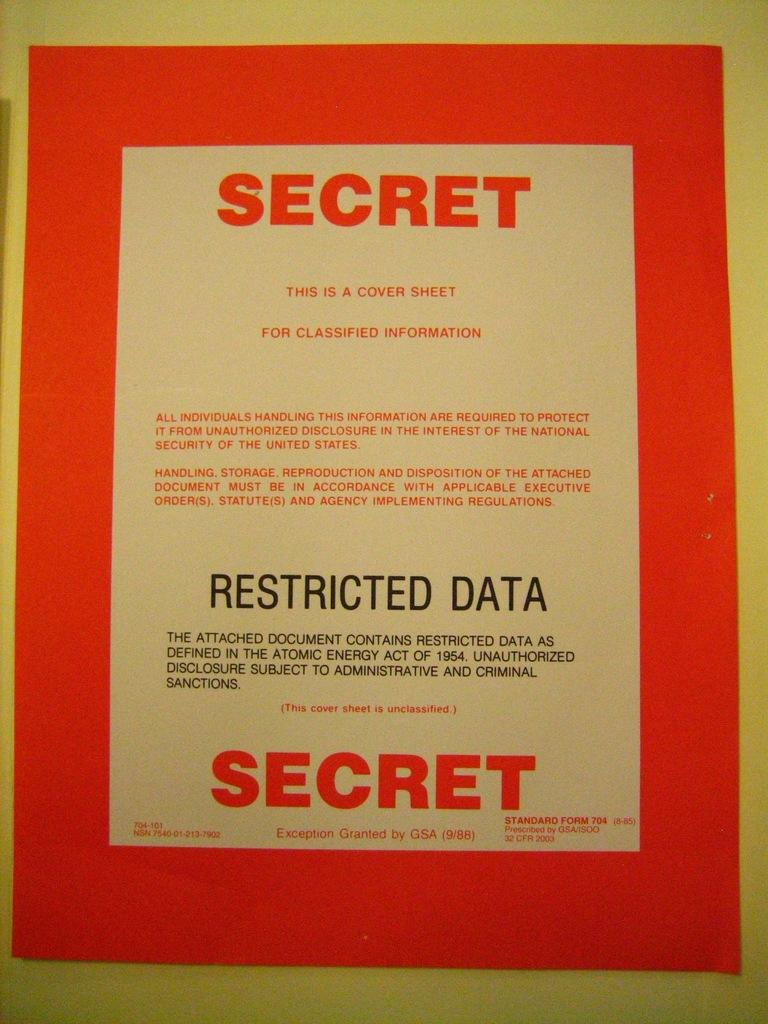<image>
Render a clear and concise summary of the photo. A manila envelope with an orange label on it stating Secret for classified information. 